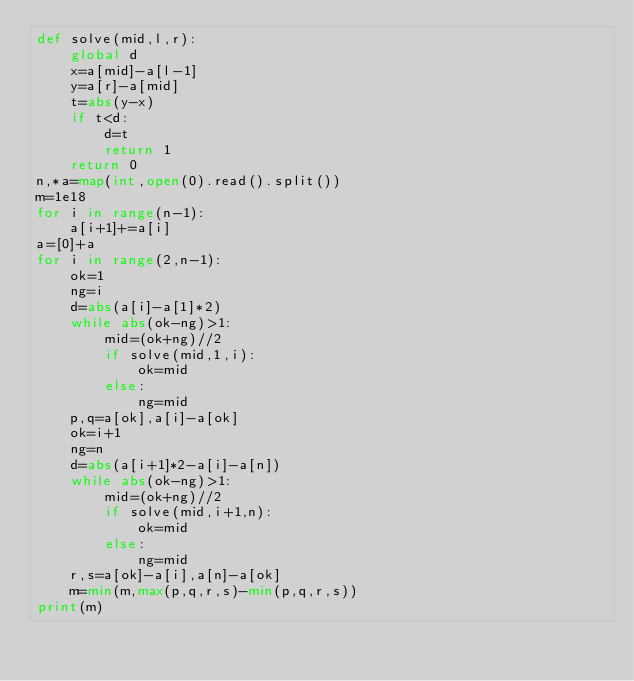Convert code to text. <code><loc_0><loc_0><loc_500><loc_500><_Python_>def solve(mid,l,r):
    global d
    x=a[mid]-a[l-1]
    y=a[r]-a[mid]
    t=abs(y-x)
    if t<d:
        d=t
        return 1
    return 0
n,*a=map(int,open(0).read().split())
m=1e18
for i in range(n-1):
    a[i+1]+=a[i]
a=[0]+a
for i in range(2,n-1):
    ok=1
    ng=i
    d=abs(a[i]-a[1]*2)
    while abs(ok-ng)>1:
        mid=(ok+ng)//2
        if solve(mid,1,i):
            ok=mid
        else:
            ng=mid
    p,q=a[ok],a[i]-a[ok]
    ok=i+1
    ng=n
    d=abs(a[i+1]*2-a[i]-a[n])
    while abs(ok-ng)>1:
        mid=(ok+ng)//2
        if solve(mid,i+1,n):
            ok=mid
        else:
            ng=mid
    r,s=a[ok]-a[i],a[n]-a[ok]
    m=min(m,max(p,q,r,s)-min(p,q,r,s))
print(m)</code> 